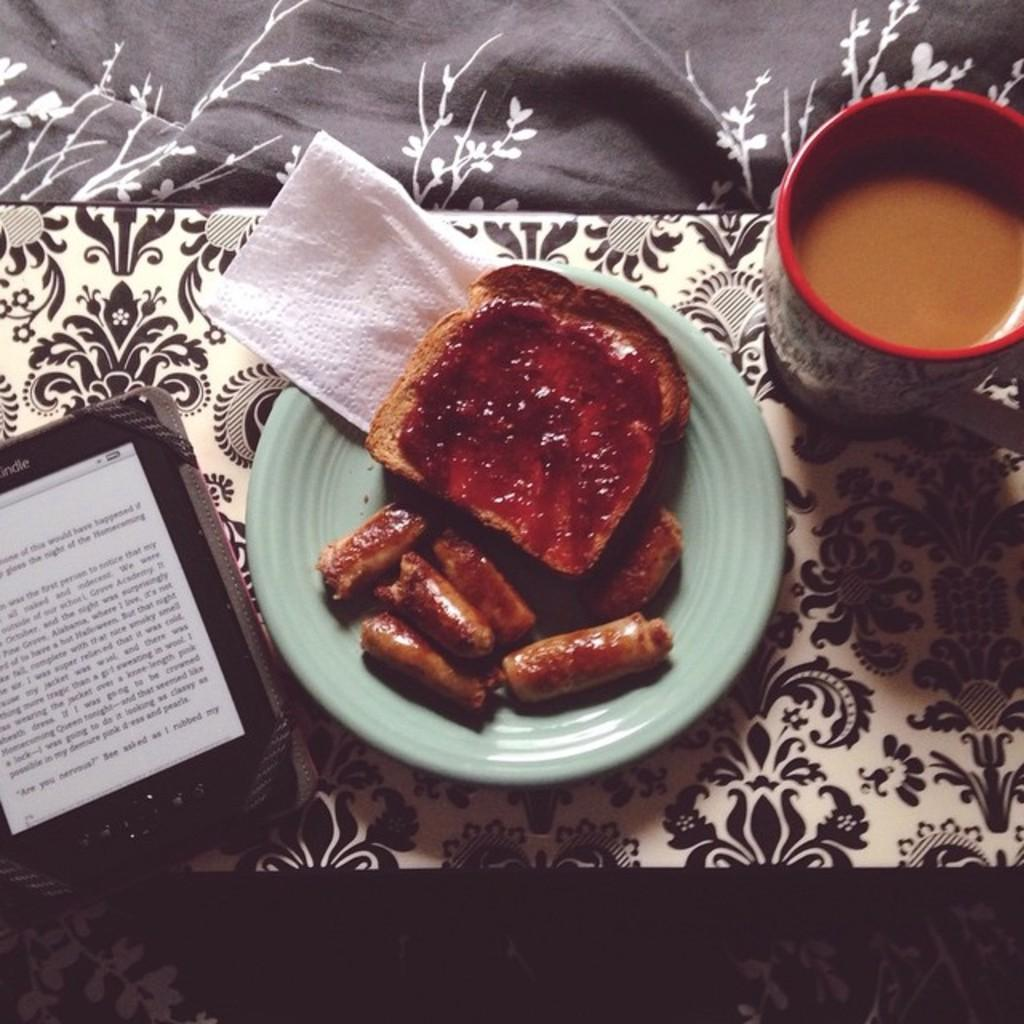<image>
Render a clear and concise summary of the photo. A picture of some breakfast with the word my on a kindle next to the food. 